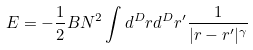Convert formula to latex. <formula><loc_0><loc_0><loc_500><loc_500>E = - \frac { 1 } { 2 } B N ^ { 2 } \int d ^ { D } r d ^ { D } r ^ { \prime } \frac { 1 } { | r - r ^ { \prime } | ^ { \gamma } }</formula> 